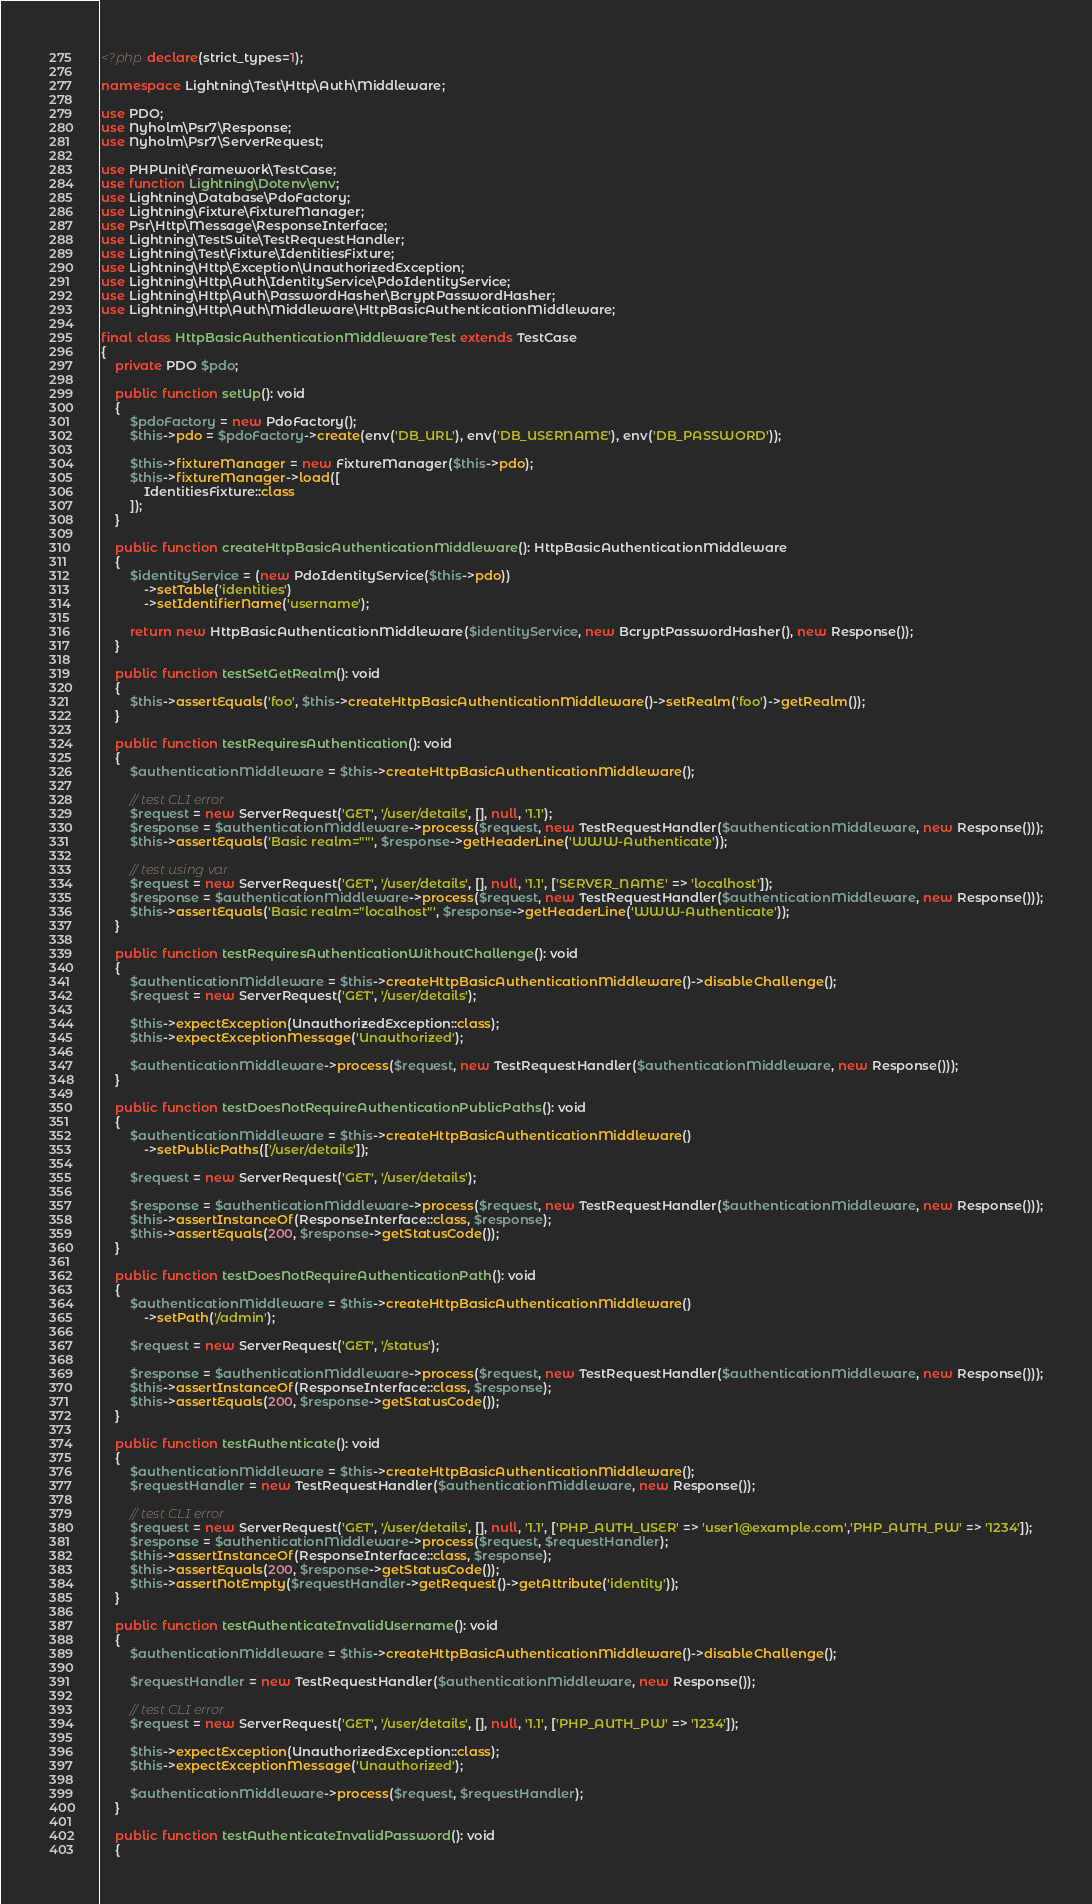Convert code to text. <code><loc_0><loc_0><loc_500><loc_500><_PHP_><?php declare(strict_types=1);

namespace Lightning\Test\Http\Auth\Middleware;

use PDO;
use Nyholm\Psr7\Response;
use Nyholm\Psr7\ServerRequest;

use PHPUnit\Framework\TestCase;
use function Lightning\Dotenv\env;
use Lightning\Database\PdoFactory;
use Lightning\Fixture\FixtureManager;
use Psr\Http\Message\ResponseInterface;
use Lightning\TestSuite\TestRequestHandler;
use Lightning\Test\Fixture\IdentitiesFixture;
use Lightning\Http\Exception\UnauthorizedException;
use Lightning\Http\Auth\IdentityService\PdoIdentityService;
use Lightning\Http\Auth\PasswordHasher\BcryptPasswordHasher;
use Lightning\Http\Auth\Middleware\HttpBasicAuthenticationMiddleware;

final class HttpBasicAuthenticationMiddlewareTest extends TestCase
{
    private PDO $pdo;

    public function setUp(): void
    {
        $pdoFactory = new PdoFactory();
        $this->pdo = $pdoFactory->create(env('DB_URL'), env('DB_USERNAME'), env('DB_PASSWORD'));

        $this->fixtureManager = new FixtureManager($this->pdo);
        $this->fixtureManager->load([
            IdentitiesFixture::class
        ]);
    }

    public function createHttpBasicAuthenticationMiddleware(): HttpBasicAuthenticationMiddleware
    {
        $identityService = (new PdoIdentityService($this->pdo))
            ->setTable('identities')
            ->setIdentifierName('username');

        return new HttpBasicAuthenticationMiddleware($identityService, new BcryptPasswordHasher(), new Response());
    }

    public function testSetGetRealm(): void
    {
        $this->assertEquals('foo', $this->createHttpBasicAuthenticationMiddleware()->setRealm('foo')->getRealm());
    }

    public function testRequiresAuthentication(): void
    {
        $authenticationMiddleware = $this->createHttpBasicAuthenticationMiddleware();

        // test CLI error
        $request = new ServerRequest('GET', '/user/details', [], null, '1.1');
        $response = $authenticationMiddleware->process($request, new TestRequestHandler($authenticationMiddleware, new Response()));
        $this->assertEquals('Basic realm=""', $response->getHeaderLine('WWW-Authenticate'));

        // test using var
        $request = new ServerRequest('GET', '/user/details', [], null, '1.1', ['SERVER_NAME' => 'localhost']);
        $response = $authenticationMiddleware->process($request, new TestRequestHandler($authenticationMiddleware, new Response()));
        $this->assertEquals('Basic realm="localhost"', $response->getHeaderLine('WWW-Authenticate'));
    }

    public function testRequiresAuthenticationWithoutChallenge(): void
    {
        $authenticationMiddleware = $this->createHttpBasicAuthenticationMiddleware()->disableChallenge();
        $request = new ServerRequest('GET', '/user/details');

        $this->expectException(UnauthorizedException::class);
        $this->expectExceptionMessage('Unauthorized');

        $authenticationMiddleware->process($request, new TestRequestHandler($authenticationMiddleware, new Response()));
    }

    public function testDoesNotRequireAuthenticationPublicPaths(): void
    {
        $authenticationMiddleware = $this->createHttpBasicAuthenticationMiddleware()
            ->setPublicPaths(['/user/details']);

        $request = new ServerRequest('GET', '/user/details');

        $response = $authenticationMiddleware->process($request, new TestRequestHandler($authenticationMiddleware, new Response()));
        $this->assertInstanceOf(ResponseInterface::class, $response);
        $this->assertEquals(200, $response->getStatusCode());
    }

    public function testDoesNotRequireAuthenticationPath(): void
    {
        $authenticationMiddleware = $this->createHttpBasicAuthenticationMiddleware()
            ->setPath('/admin');

        $request = new ServerRequest('GET', '/status');

        $response = $authenticationMiddleware->process($request, new TestRequestHandler($authenticationMiddleware, new Response()));
        $this->assertInstanceOf(ResponseInterface::class, $response);
        $this->assertEquals(200, $response->getStatusCode());
    }

    public function testAuthenticate(): void
    {
        $authenticationMiddleware = $this->createHttpBasicAuthenticationMiddleware();
        $requestHandler = new TestRequestHandler($authenticationMiddleware, new Response());

        // test CLI error
        $request = new ServerRequest('GET', '/user/details', [], null, '1.1', ['PHP_AUTH_USER' => 'user1@example.com','PHP_AUTH_PW' => '1234']);
        $response = $authenticationMiddleware->process($request, $requestHandler);
        $this->assertInstanceOf(ResponseInterface::class, $response);
        $this->assertEquals(200, $response->getStatusCode());
        $this->assertNotEmpty($requestHandler->getRequest()->getAttribute('identity'));
    }

    public function testAuthenticateInvalidUsername(): void
    {
        $authenticationMiddleware = $this->createHttpBasicAuthenticationMiddleware()->disableChallenge();

        $requestHandler = new TestRequestHandler($authenticationMiddleware, new Response());

        // test CLI error
        $request = new ServerRequest('GET', '/user/details', [], null, '1.1', ['PHP_AUTH_PW' => '1234']);

        $this->expectException(UnauthorizedException::class);
        $this->expectExceptionMessage('Unauthorized');

        $authenticationMiddleware->process($request, $requestHandler);
    }

    public function testAuthenticateInvalidPassword(): void
    {</code> 